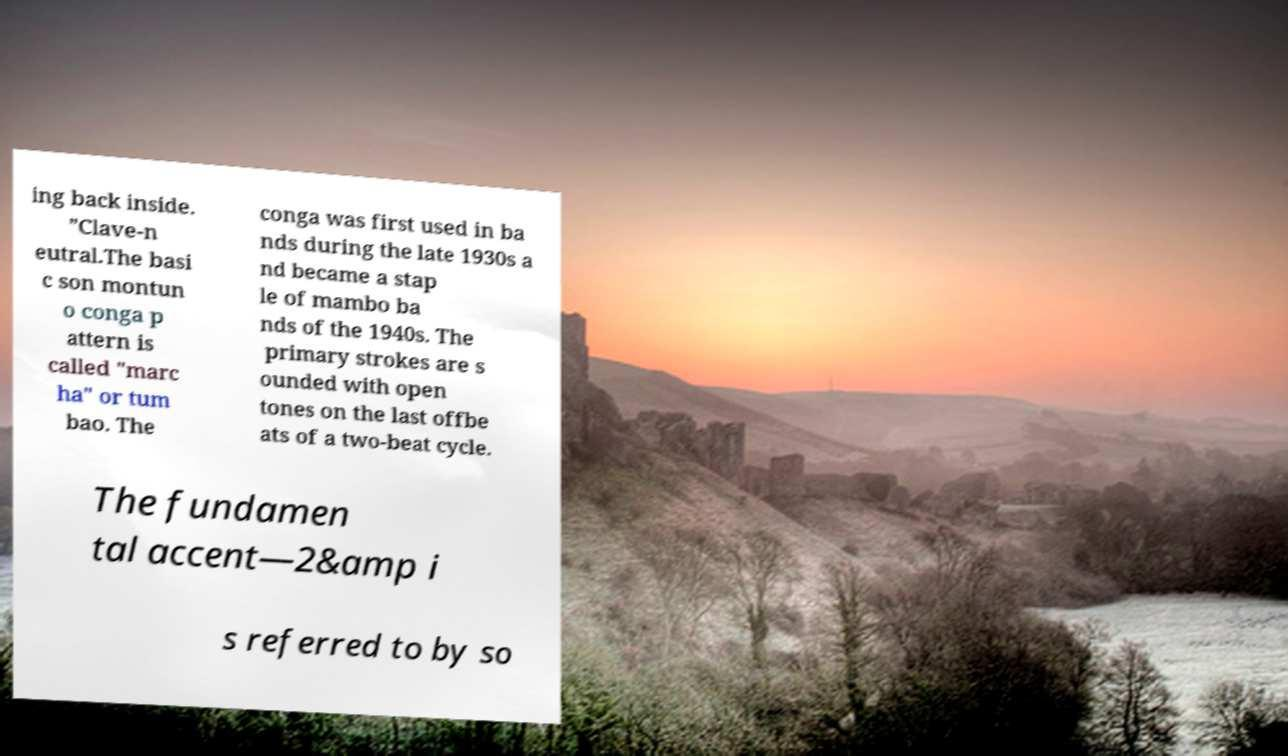For documentation purposes, I need the text within this image transcribed. Could you provide that? ing back inside. ”Clave-n eutral.The basi c son montun o conga p attern is called "marc ha" or tum bao. The conga was first used in ba nds during the late 1930s a nd became a stap le of mambo ba nds of the 1940s. The primary strokes are s ounded with open tones on the last offbe ats of a two-beat cycle. The fundamen tal accent—2&amp i s referred to by so 